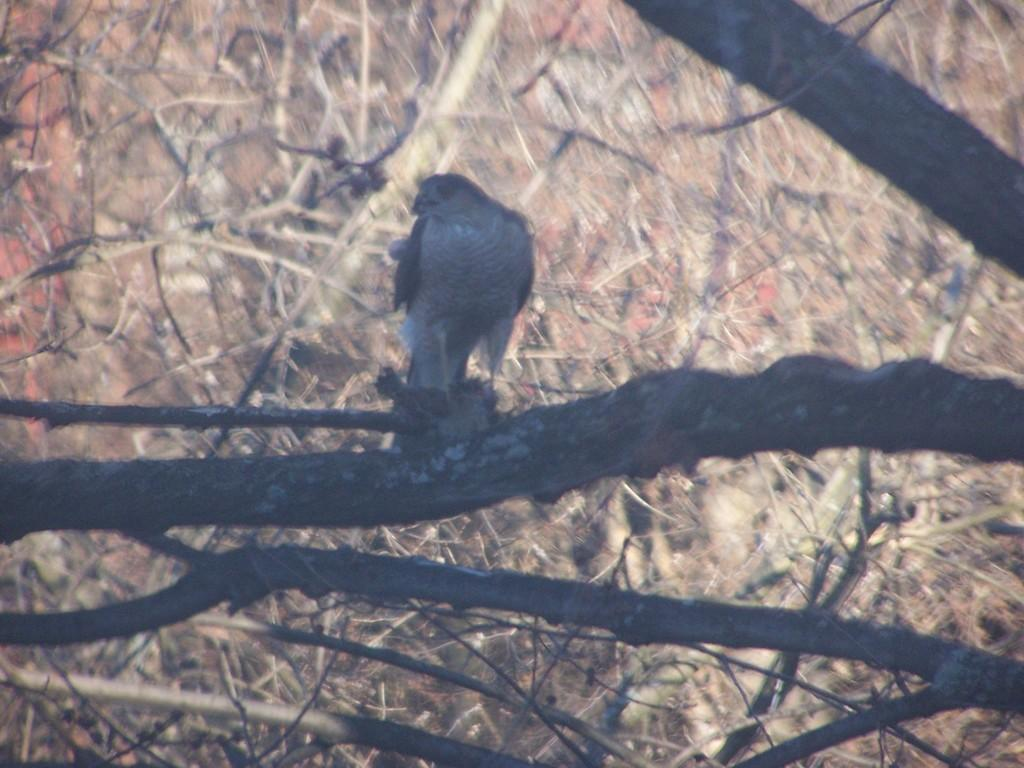What type of animal can be seen in the image? There is a bird in the image. Where is the bird located? The bird is sitting on a branch of a tree. What can be seen in the background of the image? There are trees in the background of the image. What type of wall can be seen in the image? There is no wall present in the image; it features a bird sitting on a tree branch. What type of yam is the bird holding in its beak? The bird is not holding a yam in its beak, as there is no yam present in the image. 